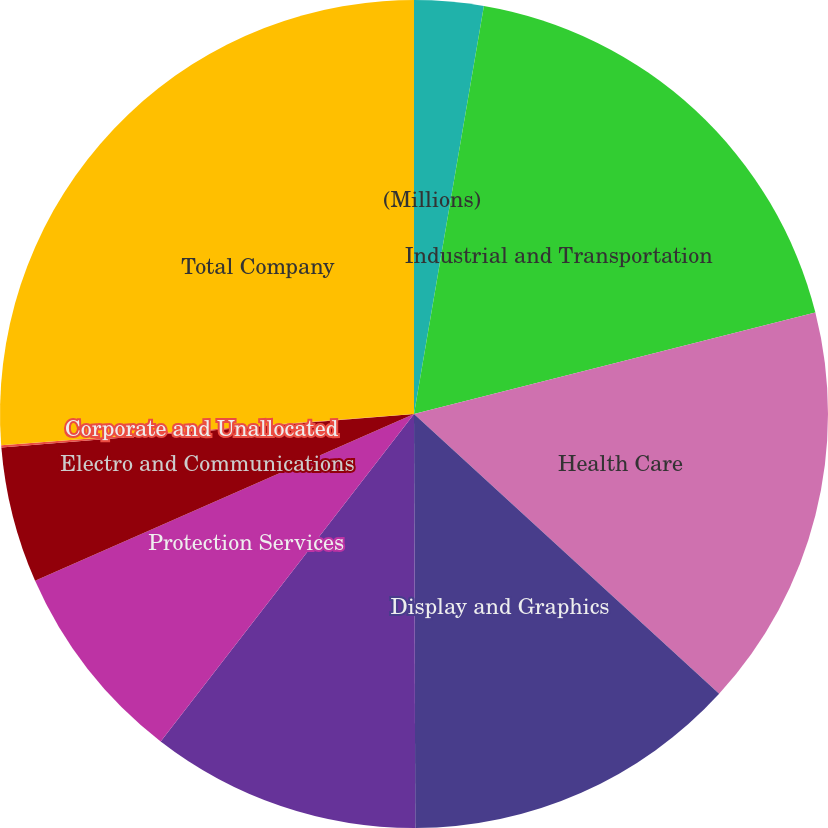Convert chart to OTSL. <chart><loc_0><loc_0><loc_500><loc_500><pie_chart><fcel>(Millions)<fcel>Industrial and Transportation<fcel>Health Care<fcel>Display and Graphics<fcel>Consumer and Office<fcel>Protection Services<fcel>Electro and Communications<fcel>Corporate and Unallocated<fcel>Total Company<nl><fcel>2.7%<fcel>18.36%<fcel>15.75%<fcel>13.14%<fcel>10.53%<fcel>7.92%<fcel>5.31%<fcel>0.09%<fcel>26.2%<nl></chart> 